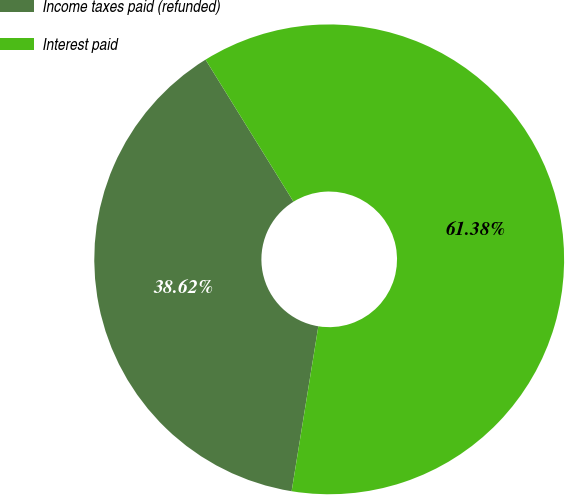<chart> <loc_0><loc_0><loc_500><loc_500><pie_chart><fcel>Income taxes paid (refunded)<fcel>Interest paid<nl><fcel>38.62%<fcel>61.38%<nl></chart> 